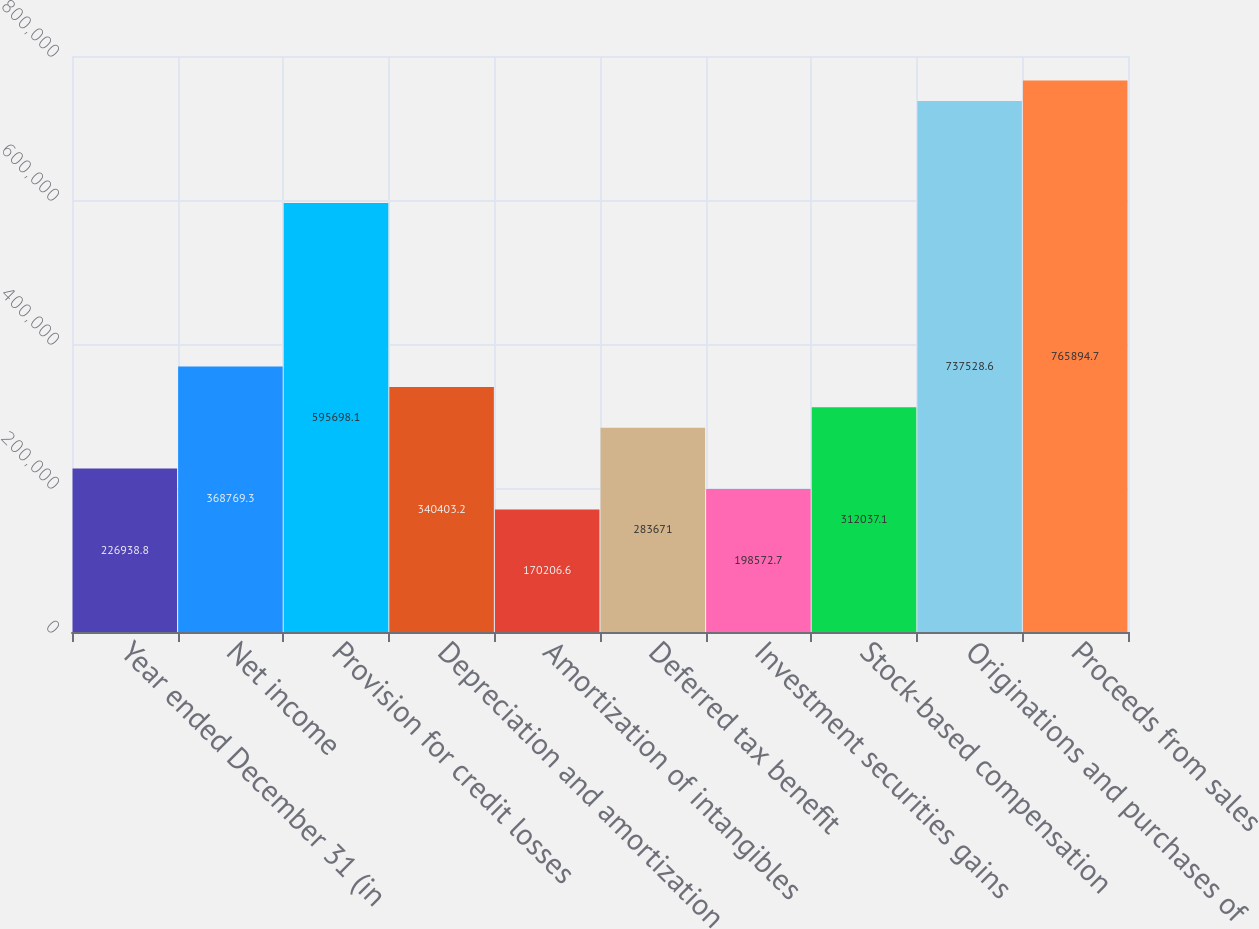<chart> <loc_0><loc_0><loc_500><loc_500><bar_chart><fcel>Year ended December 31 (in<fcel>Net income<fcel>Provision for credit losses<fcel>Depreciation and amortization<fcel>Amortization of intangibles<fcel>Deferred tax benefit<fcel>Investment securities gains<fcel>Stock-based compensation<fcel>Originations and purchases of<fcel>Proceeds from sales<nl><fcel>226939<fcel>368769<fcel>595698<fcel>340403<fcel>170207<fcel>283671<fcel>198573<fcel>312037<fcel>737529<fcel>765895<nl></chart> 